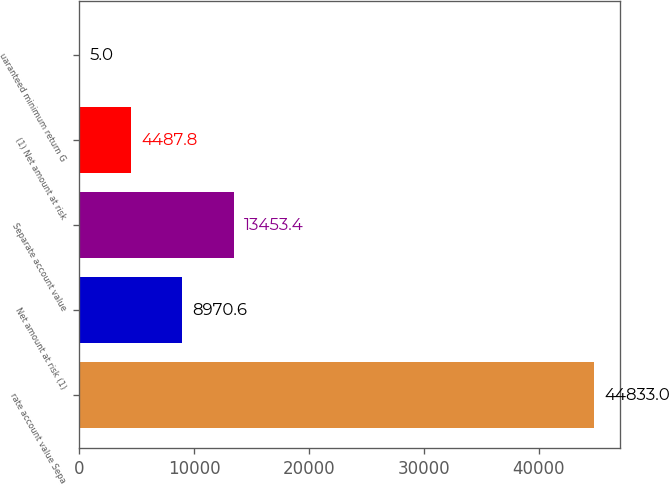<chart> <loc_0><loc_0><loc_500><loc_500><bar_chart><fcel>rate account value Sepa<fcel>Net amount at risk (1)<fcel>Separate account value<fcel>(1) Net amount at risk<fcel>uaranteed minimum return G<nl><fcel>44833<fcel>8970.6<fcel>13453.4<fcel>4487.8<fcel>5<nl></chart> 